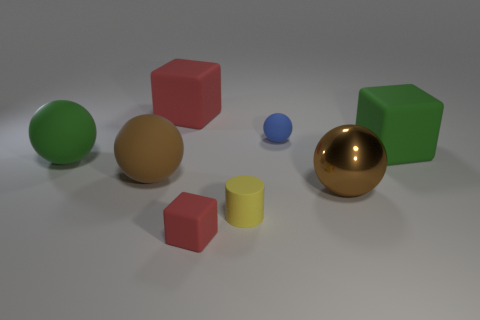Subtract all large red rubber blocks. How many blocks are left? 2 Add 1 large brown objects. How many objects exist? 9 Subtract all blue balls. How many balls are left? 3 Subtract 1 cylinders. How many cylinders are left? 0 Subtract all cubes. How many objects are left? 5 Subtract all gray blocks. Subtract all purple balls. How many blocks are left? 3 Subtract all brown spheres. How many red blocks are left? 2 Subtract all tiny matte things. Subtract all big green shiny cylinders. How many objects are left? 5 Add 5 big green cubes. How many big green cubes are left? 6 Add 5 small blue things. How many small blue things exist? 6 